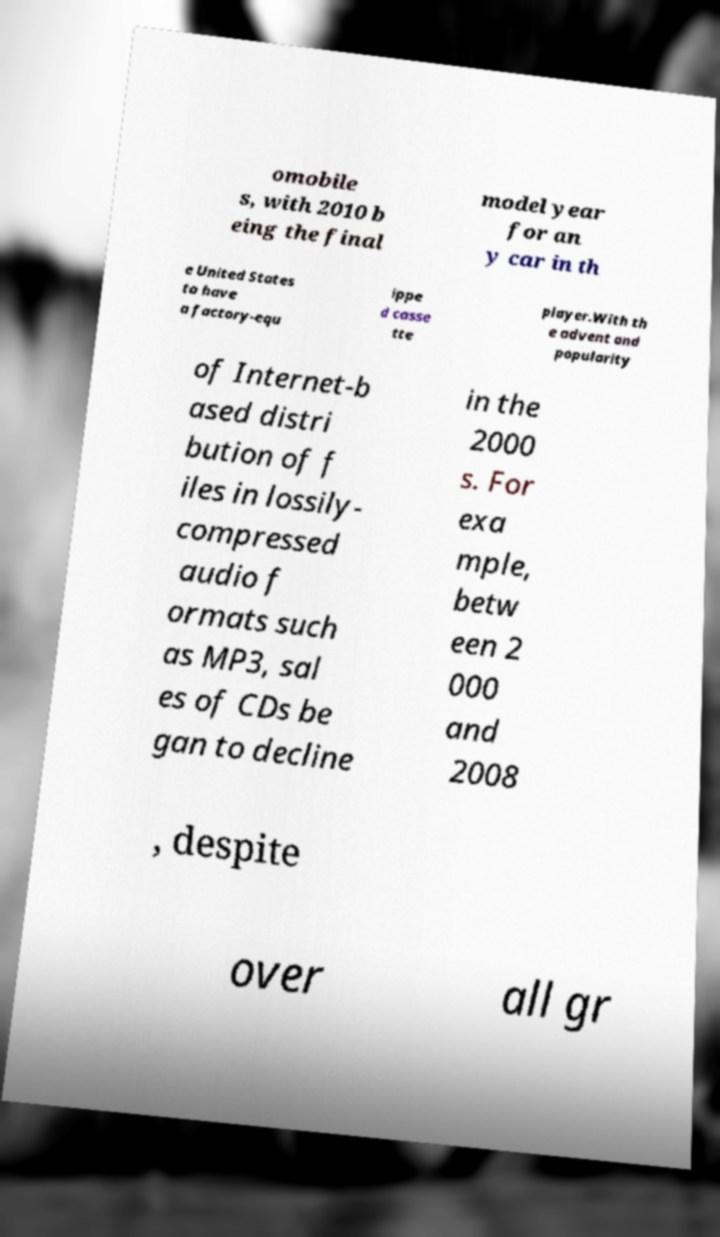Could you assist in decoding the text presented in this image and type it out clearly? omobile s, with 2010 b eing the final model year for an y car in th e United States to have a factory-equ ippe d casse tte player.With th e advent and popularity of Internet-b ased distri bution of f iles in lossily- compressed audio f ormats such as MP3, sal es of CDs be gan to decline in the 2000 s. For exa mple, betw een 2 000 and 2008 , despite over all gr 